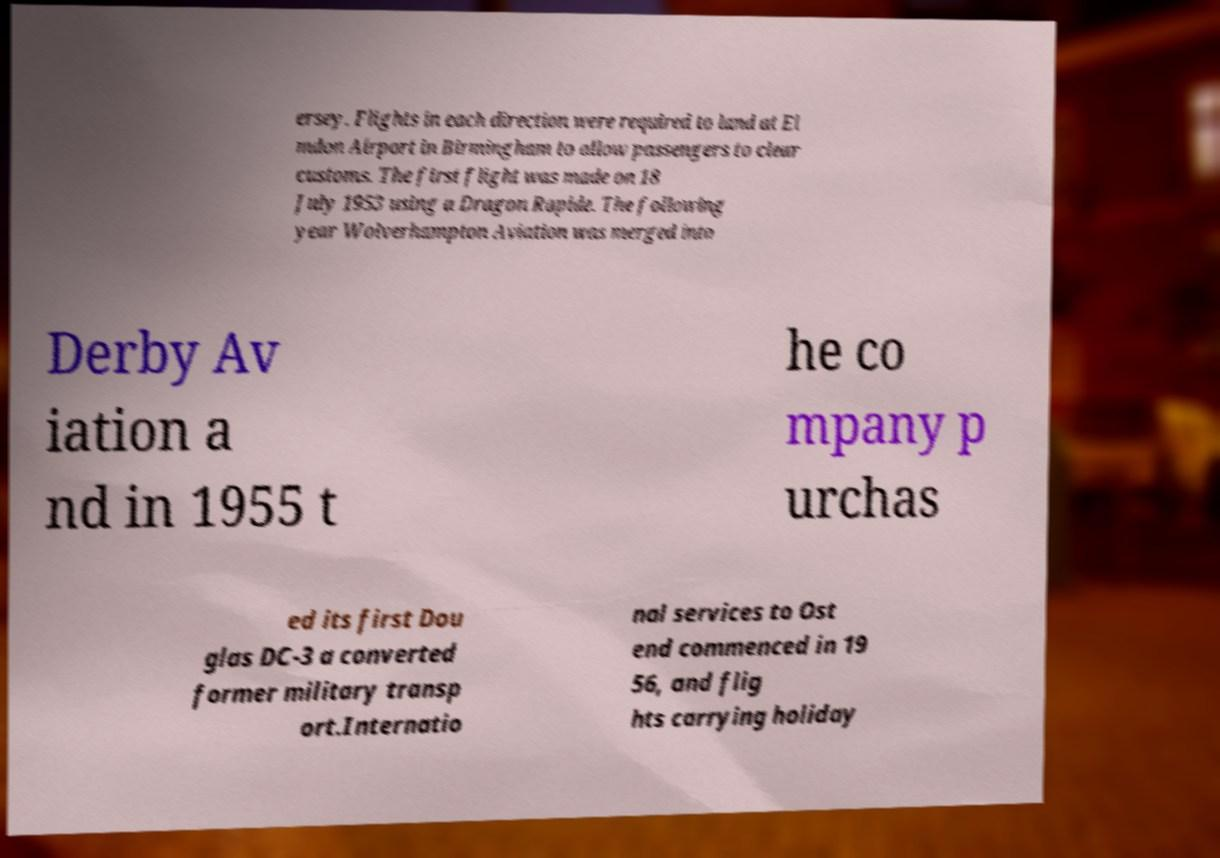Can you read and provide the text displayed in the image?This photo seems to have some interesting text. Can you extract and type it out for me? ersey. Flights in each direction were required to land at El mdon Airport in Birmingham to allow passengers to clear customs. The first flight was made on 18 July 1953 using a Dragon Rapide. The following year Wolverhampton Aviation was merged into Derby Av iation a nd in 1955 t he co mpany p urchas ed its first Dou glas DC-3 a converted former military transp ort.Internatio nal services to Ost end commenced in 19 56, and flig hts carrying holiday 